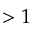<formula> <loc_0><loc_0><loc_500><loc_500>> 1</formula> 